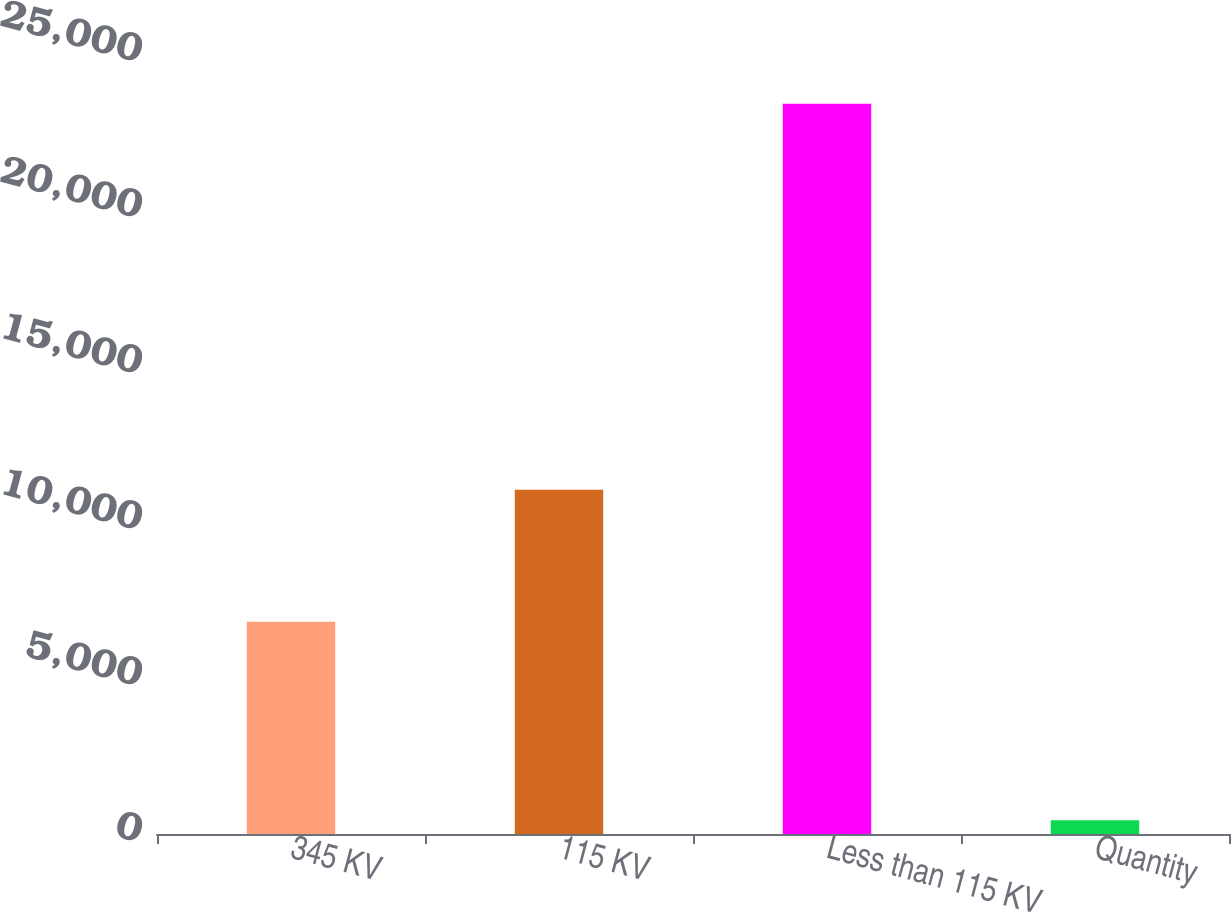<chart> <loc_0><loc_0><loc_500><loc_500><bar_chart><fcel>345 KV<fcel>115 KV<fcel>Less than 115 KV<fcel>Quantity<nl><fcel>6800<fcel>11034<fcel>23403<fcel>437<nl></chart> 